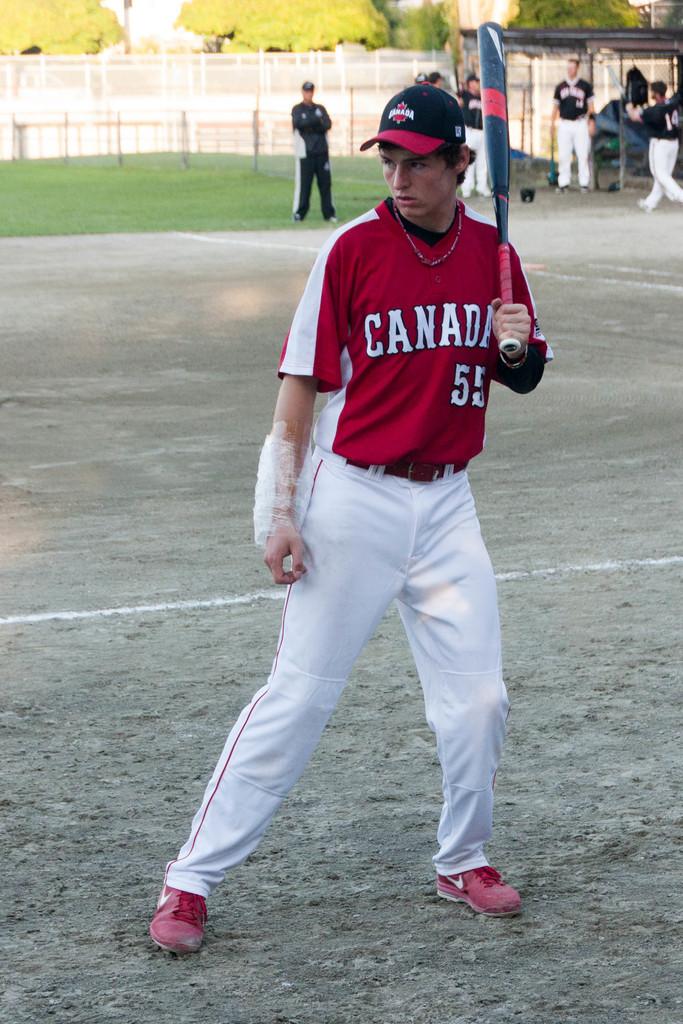What is the name of the team the batter is on?
Your answer should be compact. Canada. 